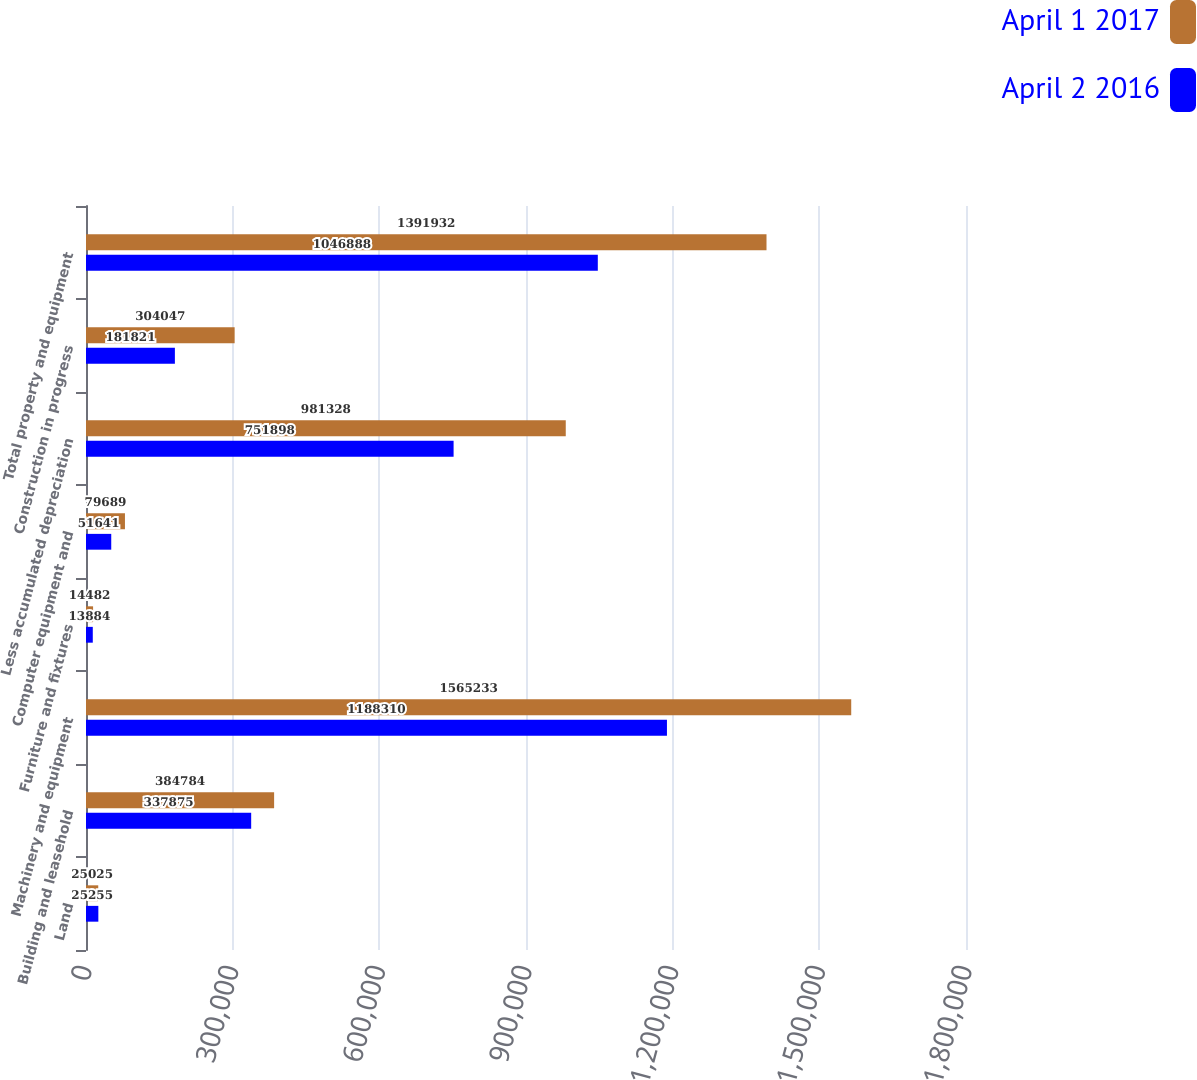Convert chart to OTSL. <chart><loc_0><loc_0><loc_500><loc_500><stacked_bar_chart><ecel><fcel>Land<fcel>Building and leasehold<fcel>Machinery and equipment<fcel>Furniture and fixtures<fcel>Computer equipment and<fcel>Less accumulated depreciation<fcel>Construction in progress<fcel>Total property and equipment<nl><fcel>April 1 2017<fcel>25025<fcel>384784<fcel>1.56523e+06<fcel>14482<fcel>79689<fcel>981328<fcel>304047<fcel>1.39193e+06<nl><fcel>April 2 2016<fcel>25255<fcel>337875<fcel>1.18831e+06<fcel>13884<fcel>51641<fcel>751898<fcel>181821<fcel>1.04689e+06<nl></chart> 